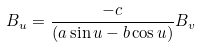<formula> <loc_0><loc_0><loc_500><loc_500>B _ { u } = \frac { - c } { ( a \sin { u } - b \cos u ) } B _ { v }</formula> 